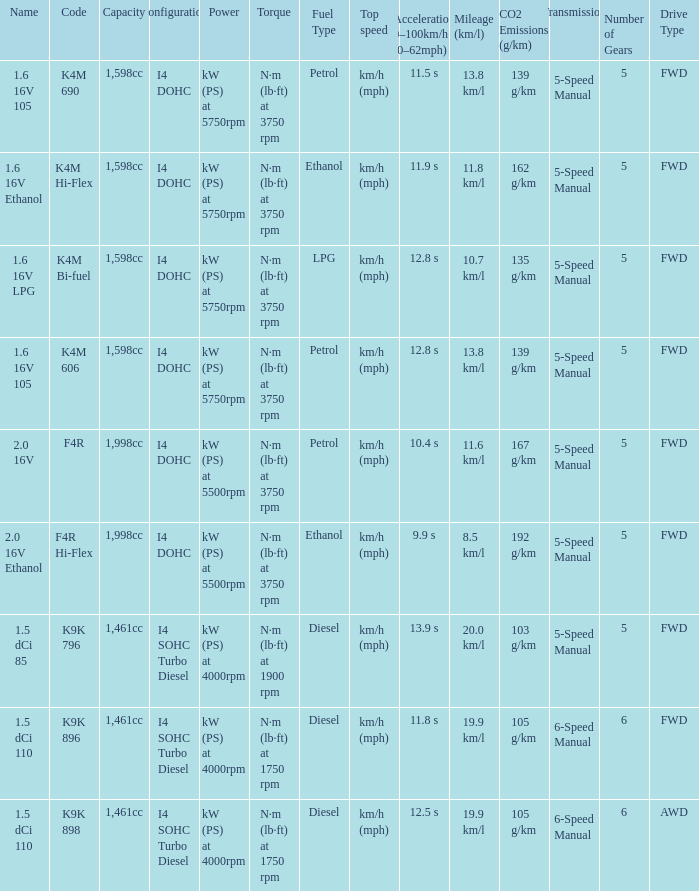What is the code of 1.5 dci 110, which has a capacity of 1,461cc? K9K 896, K9K 898. 